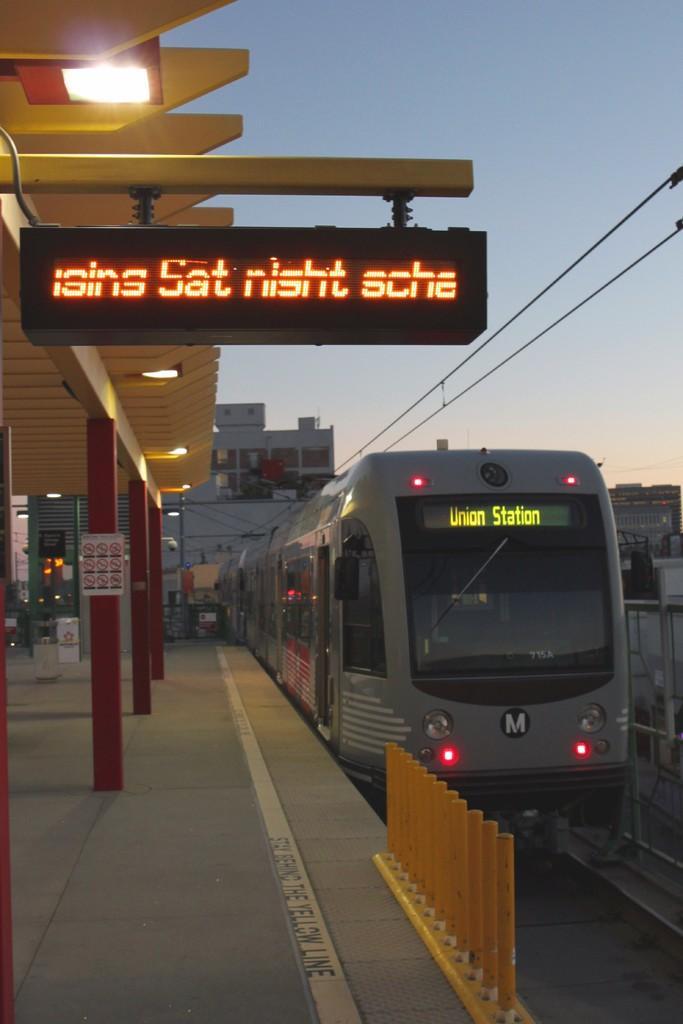Can you describe this image briefly? In the foreground of this image, there is a train moving on the track. There are safety poles on the platform, a display board, a shed and the lights. In the background, there are buildings, poles, cables and the sky. 